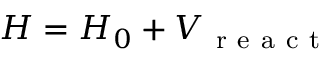<formula> <loc_0><loc_0><loc_500><loc_500>H = H _ { 0 } + V _ { r e a c t }</formula> 